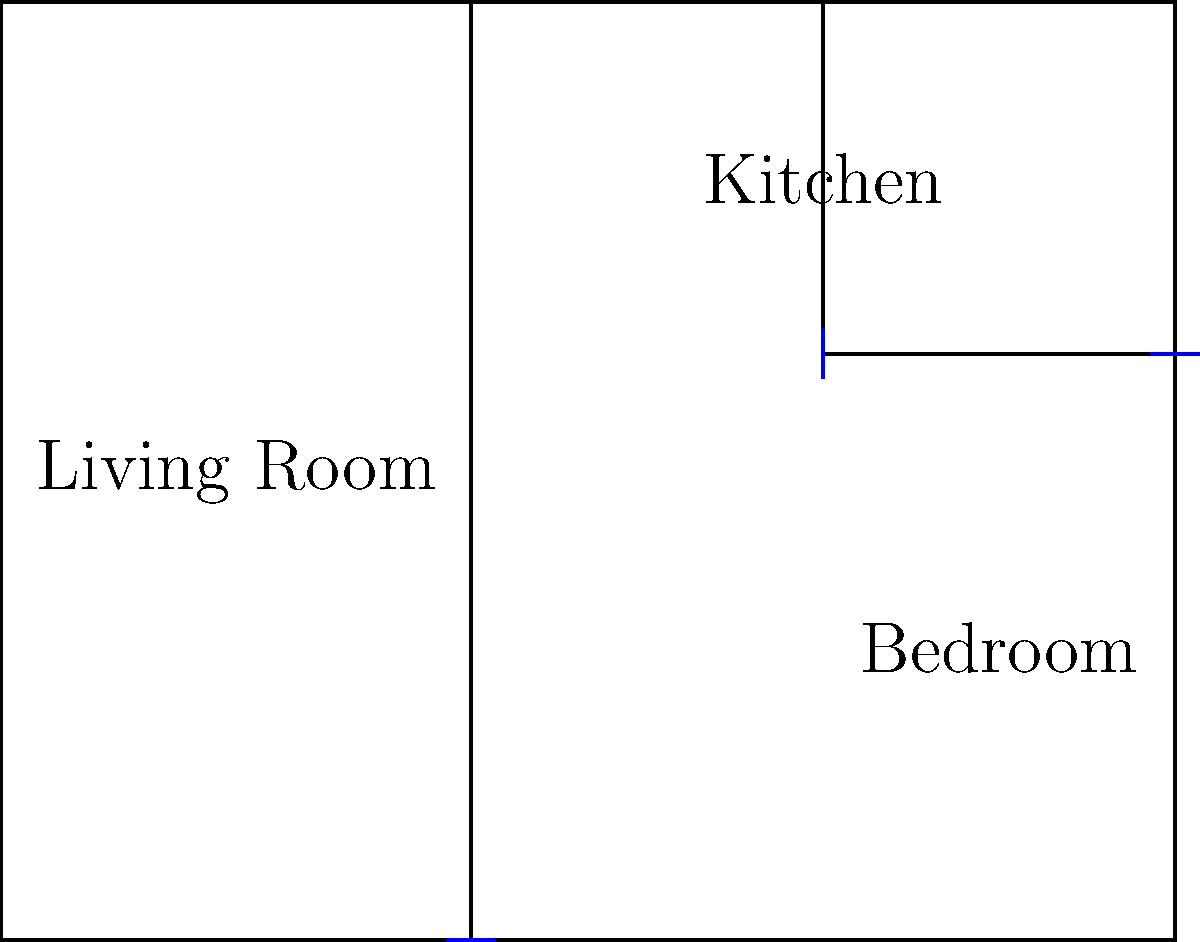Based on the floor plan of the Zungu family's main house in 'Isithembiso', which room is located in the bottom right corner of the layout? To answer this question, let's analyze the floor plan step-by-step:

1. The floor plan shows a rectangular layout divided into three main areas.
2. The largest area on the left is labeled "Living Room".
3. The top right area is labeled "Kitchen".
4. The bottom right area, which is the smallest room in the layout, is labeled "Bedroom".
5. The question asks specifically about the room in the bottom right corner.
6. Looking at the layout, we can clearly see that the Bedroom occupies this position.

Therefore, the room located in the bottom right corner of the Zungu family's main house layout in 'Isithembiso' is the Bedroom.
Answer: Bedroom 